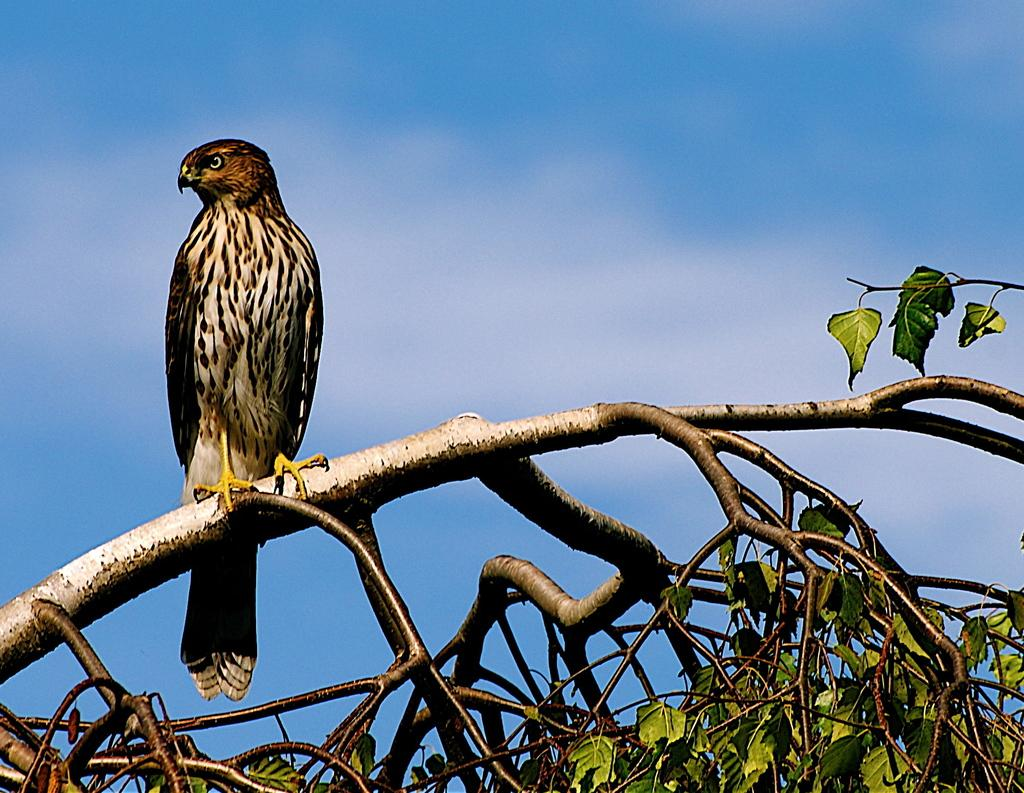What type of animal is in the image? There is a bird in the image. Can you describe the bird's appearance? The bird is brown and black in color. What is the bird doing in the image? The bird is standing on a branch. What else can be seen in the image besides the bird? There are trees in the image. What is the color of the trees? The trees are green in color. What is visible in the background of the image? The sky is visible in the background of the image. What is the color of the sky? The sky is blue in color. Where is the pail located in the image? There is no pail present in the image. How many flies can be seen buzzing around the bird in the image? There are no flies present in the image. 